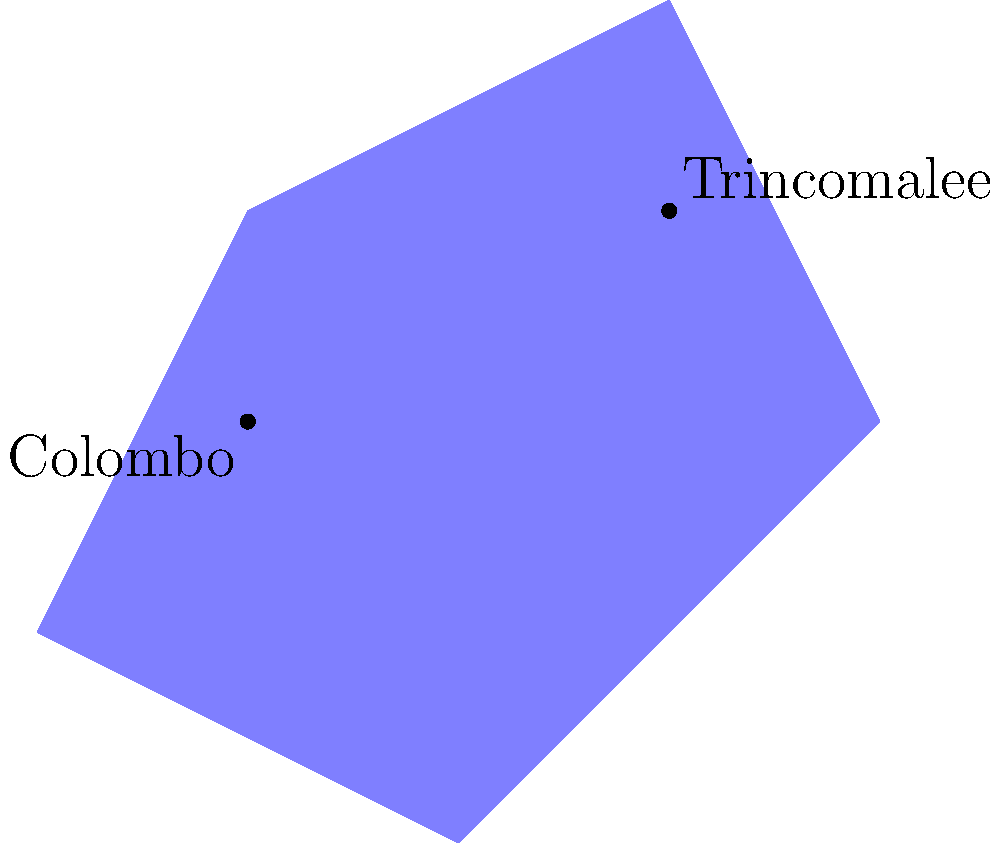Using the provided coordinate system map of Sri Lanka, identify the approximate coordinates of Trincomalee, a strategically important port city that has seen significant changes in control over the past century. Express your answer as $(x, y)$ coordinates. To determine the approximate coordinates of Trincomalee, we need to follow these steps:

1. Observe the map and locate Trincomalee, which is labeled in the northeastern part of the island.

2. Note that the x-axis represents longitude and the y-axis represents latitude.

3. Estimate the position of Trincomalee relative to the grid lines:
   - On the x-axis (longitude), Trincomalee appears to be slightly right of the 3rd vertical grid line.
   - On the y-axis (latitude), Trincomalee is between the 2nd and 3rd horizontal grid lines, closer to the 2nd.

4. Based on these observations, we can approximate the coordinates as:
   - x-coordinate (longitude): approximately 3
   - y-coordinate (latitude): approximately 2

5. Therefore, the approximate coordinates of Trincomalee can be expressed as $(3, 2)$.

This coordinate system allows us to track the territorial changes in Sri Lanka over the past century, particularly focusing on strategically important locations like Trincomalee, which has been subject to various political and military influences during colonial times and post-independence conflicts.
Answer: $(3, 2)$ 